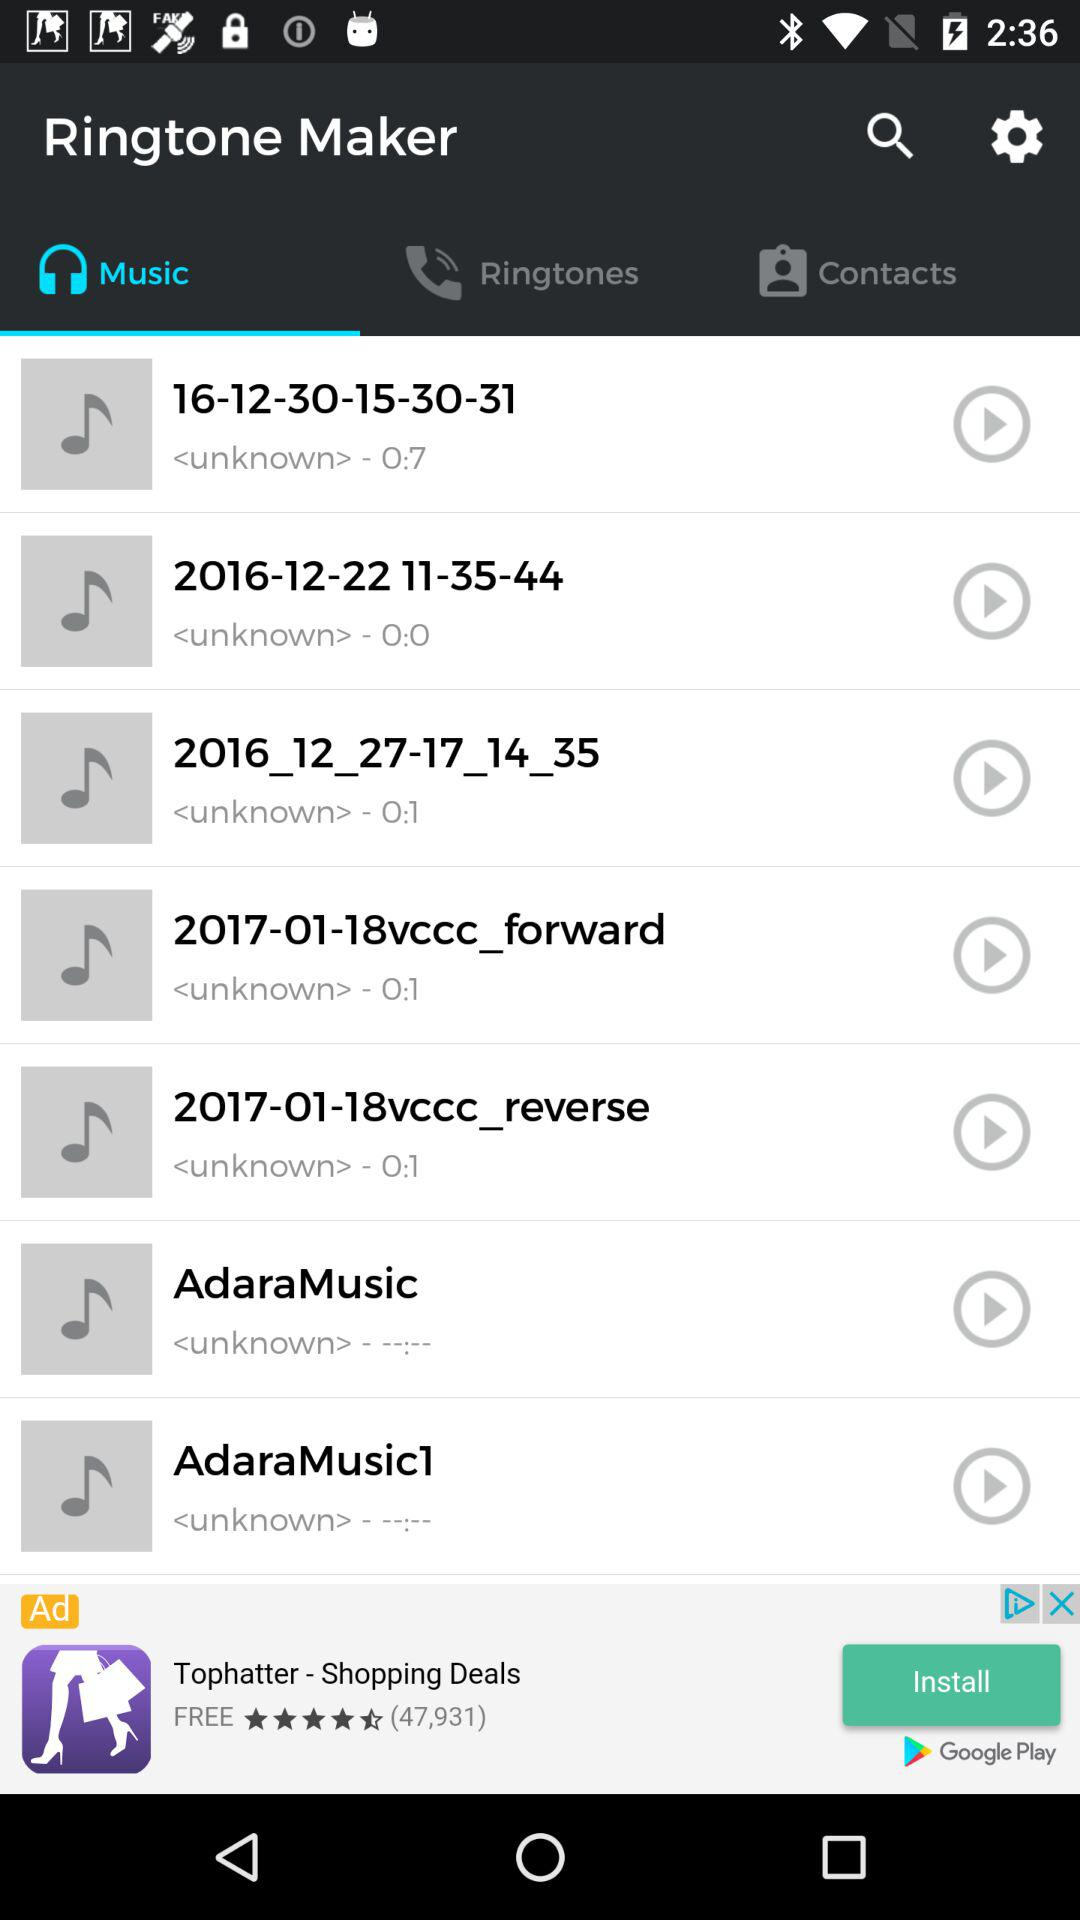Which tab are we on? You are on the "Music" tab. 